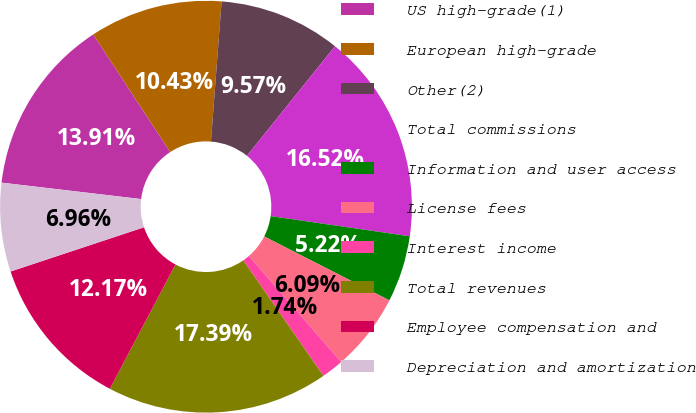<chart> <loc_0><loc_0><loc_500><loc_500><pie_chart><fcel>US high-grade(1)<fcel>European high-grade<fcel>Other(2)<fcel>Total commissions<fcel>Information and user access<fcel>License fees<fcel>Interest income<fcel>Total revenues<fcel>Employee compensation and<fcel>Depreciation and amortization<nl><fcel>13.91%<fcel>10.43%<fcel>9.57%<fcel>16.52%<fcel>5.22%<fcel>6.09%<fcel>1.74%<fcel>17.39%<fcel>12.17%<fcel>6.96%<nl></chart> 